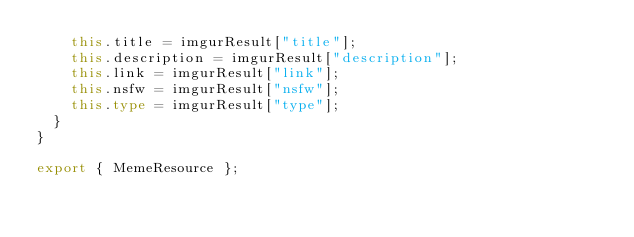Convert code to text. <code><loc_0><loc_0><loc_500><loc_500><_TypeScript_>    this.title = imgurResult["title"];
    this.description = imgurResult["description"];
    this.link = imgurResult["link"];
    this.nsfw = imgurResult["nsfw"];
    this.type = imgurResult["type"];
  }
}

export { MemeResource };
</code> 